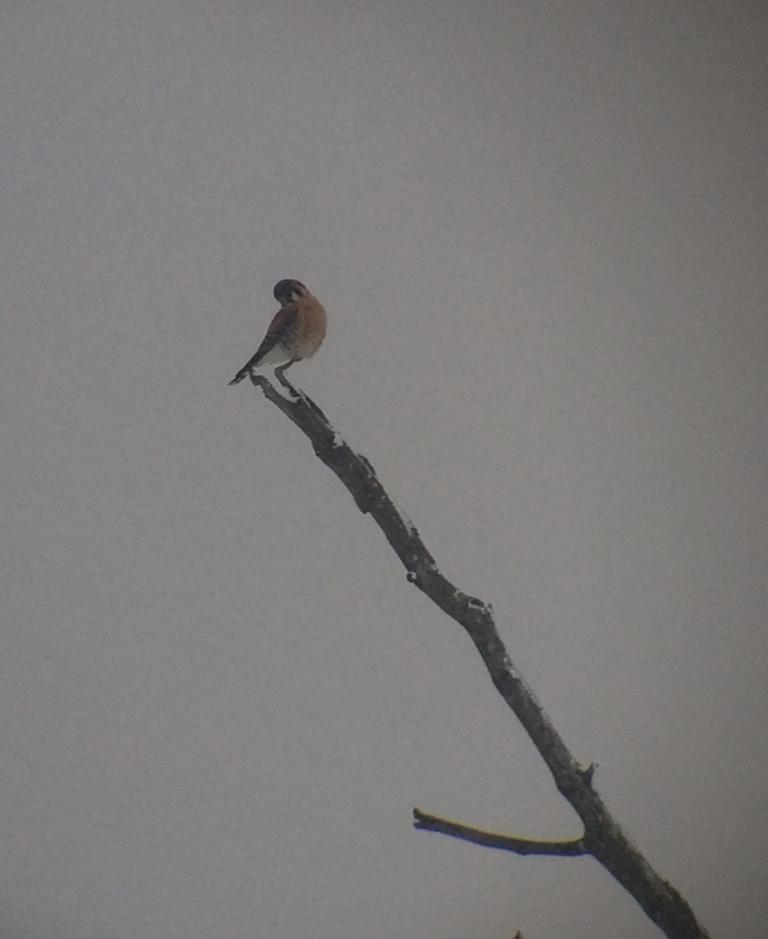What is the primary subject of the image? The primary subject of the image is a bird, which is located in the center of the image. What can be inferred about the nature of the image? The image appears to be a drawing. Are there any other elements in the image besides the bird? There is a mention of a stem in the image, although its context is unclear. How many sisters are depicted in the image? There are no sisters present in the image; it features a bird and a mention of a stem. What type of ghost can be seen interacting with the bird in the image? There is no ghost present in the image; it only features a bird and a mention of a stem. 